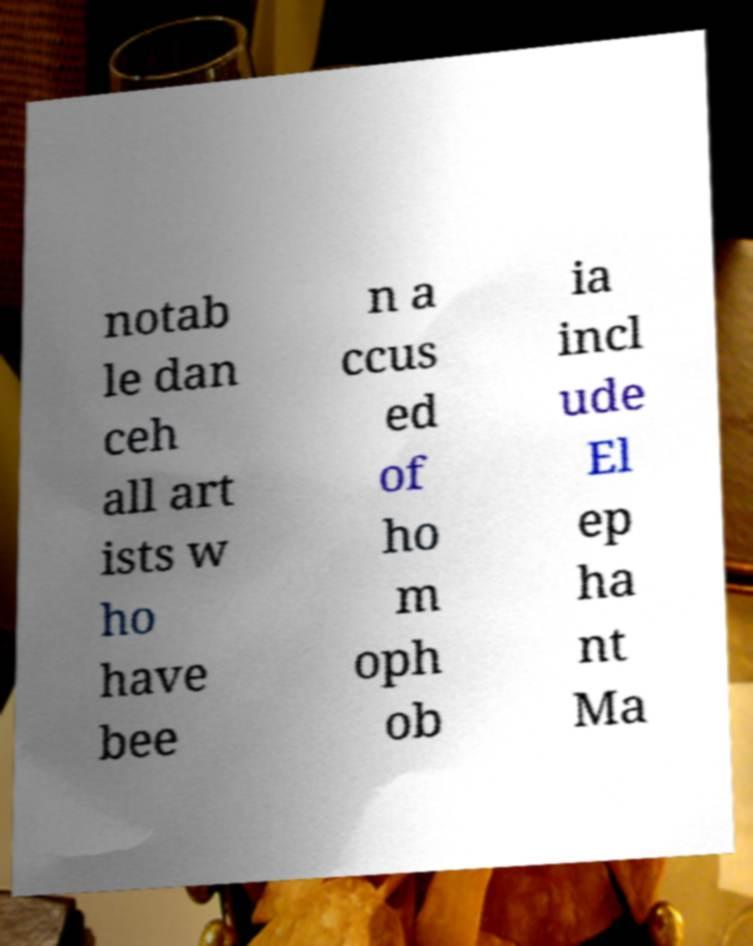Could you extract and type out the text from this image? notab le dan ceh all art ists w ho have bee n a ccus ed of ho m oph ob ia incl ude El ep ha nt Ma 